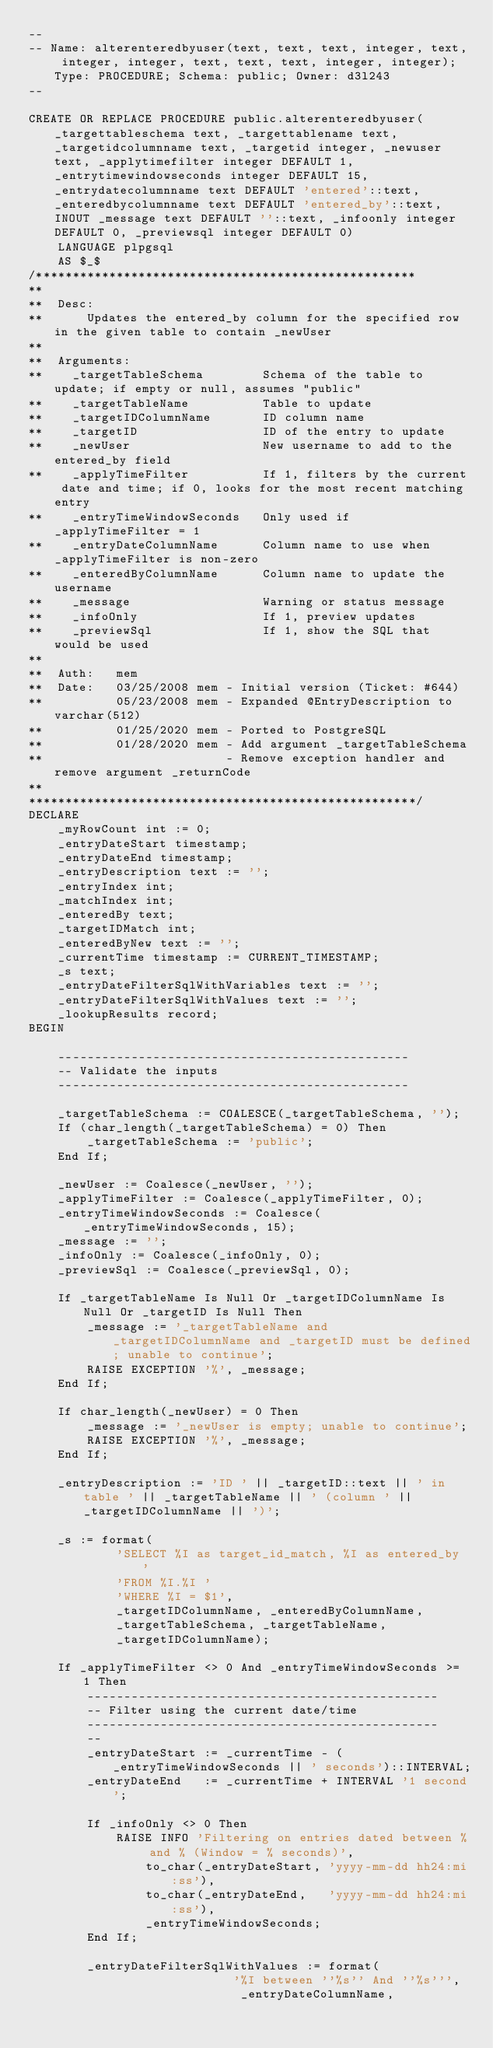Convert code to text. <code><loc_0><loc_0><loc_500><loc_500><_SQL_>--
-- Name: alterenteredbyuser(text, text, text, integer, text, integer, integer, text, text, text, integer, integer); Type: PROCEDURE; Schema: public; Owner: d3l243
--

CREATE OR REPLACE PROCEDURE public.alterenteredbyuser(_targettableschema text, _targettablename text, _targetidcolumnname text, _targetid integer, _newuser text, _applytimefilter integer DEFAULT 1, _entrytimewindowseconds integer DEFAULT 15, _entrydatecolumnname text DEFAULT 'entered'::text, _enteredbycolumnname text DEFAULT 'entered_by'::text, INOUT _message text DEFAULT ''::text, _infoonly integer DEFAULT 0, _previewsql integer DEFAULT 0)
    LANGUAGE plpgsql
    AS $_$
/****************************************************
**
**  Desc:
**      Updates the entered_by column for the specified row in the given table to contain _newUser
**
**  Arguments:
**    _targetTableSchema        Schema of the table to update; if empty or null, assumes "public"
**    _targetTableName          Table to update
**    _targetIDColumnName       ID column name
**    _targetID                 ID of the entry to update
**    _newUser                  New username to add to the entered_by field
**    _applyTimeFilter          If 1, filters by the current date and time; if 0, looks for the most recent matching entry
**    _entryTimeWindowSeconds   Only used if _applyTimeFilter = 1
**    _entryDateColumnName      Column name to use when _applyTimeFilter is non-zero
**    _enteredByColumnName      Column name to update the username
**    _message                  Warning or status message
**    _infoOnly                 If 1, preview updates
**    _previewSql               If 1, show the SQL that would be used
**
**  Auth:   mem
**  Date:   03/25/2008 mem - Initial version (Ticket: #644)
**          05/23/2008 mem - Expanded @EntryDescription to varchar(512)
**          01/25/2020 mem - Ported to PostgreSQL
**          01/28/2020 mem - Add argument _targetTableSchema
**                         - Remove exception handler and remove argument _returnCode
**
*****************************************************/
DECLARE
    _myRowCount int := 0;
    _entryDateStart timestamp;
    _entryDateEnd timestamp;
    _entryDescription text := '';
    _entryIndex int;
    _matchIndex int;
    _enteredBy text;
    _targetIDMatch int;
    _enteredByNew text := '';
    _currentTime timestamp := CURRENT_TIMESTAMP;
    _s text;
    _entryDateFilterSqlWithVariables text := '';
    _entryDateFilterSqlWithValues text := '';
    _lookupResults record;
BEGIN

    ------------------------------------------------
    -- Validate the inputs
    ------------------------------------------------

    _targetTableSchema := COALESCE(_targetTableSchema, '');
    If (char_length(_targetTableSchema) = 0) Then
        _targetTableSchema := 'public';
    End If;

    _newUser := Coalesce(_newUser, '');
    _applyTimeFilter := Coalesce(_applyTimeFilter, 0);
    _entryTimeWindowSeconds := Coalesce(_entryTimeWindowSeconds, 15);
    _message := '';
    _infoOnly := Coalesce(_infoOnly, 0);
    _previewSql := Coalesce(_previewSql, 0);

    If _targetTableName Is Null Or _targetIDColumnName Is Null Or _targetID Is Null Then
        _message := '_targetTableName and _targetIDColumnName and _targetID must be defined; unable to continue';
        RAISE EXCEPTION '%', _message;
    End If;

    If char_length(_newUser) = 0 Then
        _message := '_newUser is empty; unable to continue';
        RAISE EXCEPTION '%', _message;
    End If;

    _entryDescription := 'ID ' || _targetID::text || ' in table ' || _targetTableName || ' (column ' || _targetIDColumnName || ')';

    _s := format(
            'SELECT %I as target_id_match, %I as entered_by '
            'FROM %I.%I '
            'WHERE %I = $1',
            _targetIDColumnName, _enteredByColumnName,
            _targetTableSchema, _targetTableName,
            _targetIDColumnName);

    If _applyTimeFilter <> 0 And _entryTimeWindowSeconds >= 1 Then
        ------------------------------------------------
        -- Filter using the current date/time
        ------------------------------------------------
        --
        _entryDateStart := _currentTime - (_entryTimeWindowSeconds || ' seconds')::INTERVAL;
        _entryDateEnd   := _currentTime + INTERVAL '1 second';

        If _infoOnly <> 0 Then
            RAISE INFO 'Filtering on entries dated between % and % (Window = % seconds)',
                to_char(_entryDateStart, 'yyyy-mm-dd hh24:mi:ss'),
                to_char(_entryDateEnd,   'yyyy-mm-dd hh24:mi:ss'),
                _entryTimeWindowSeconds;
        End If;

        _entryDateFilterSqlWithValues := format(
                            '%I between ''%s'' And ''%s''',
                             _entryDateColumnName,</code> 